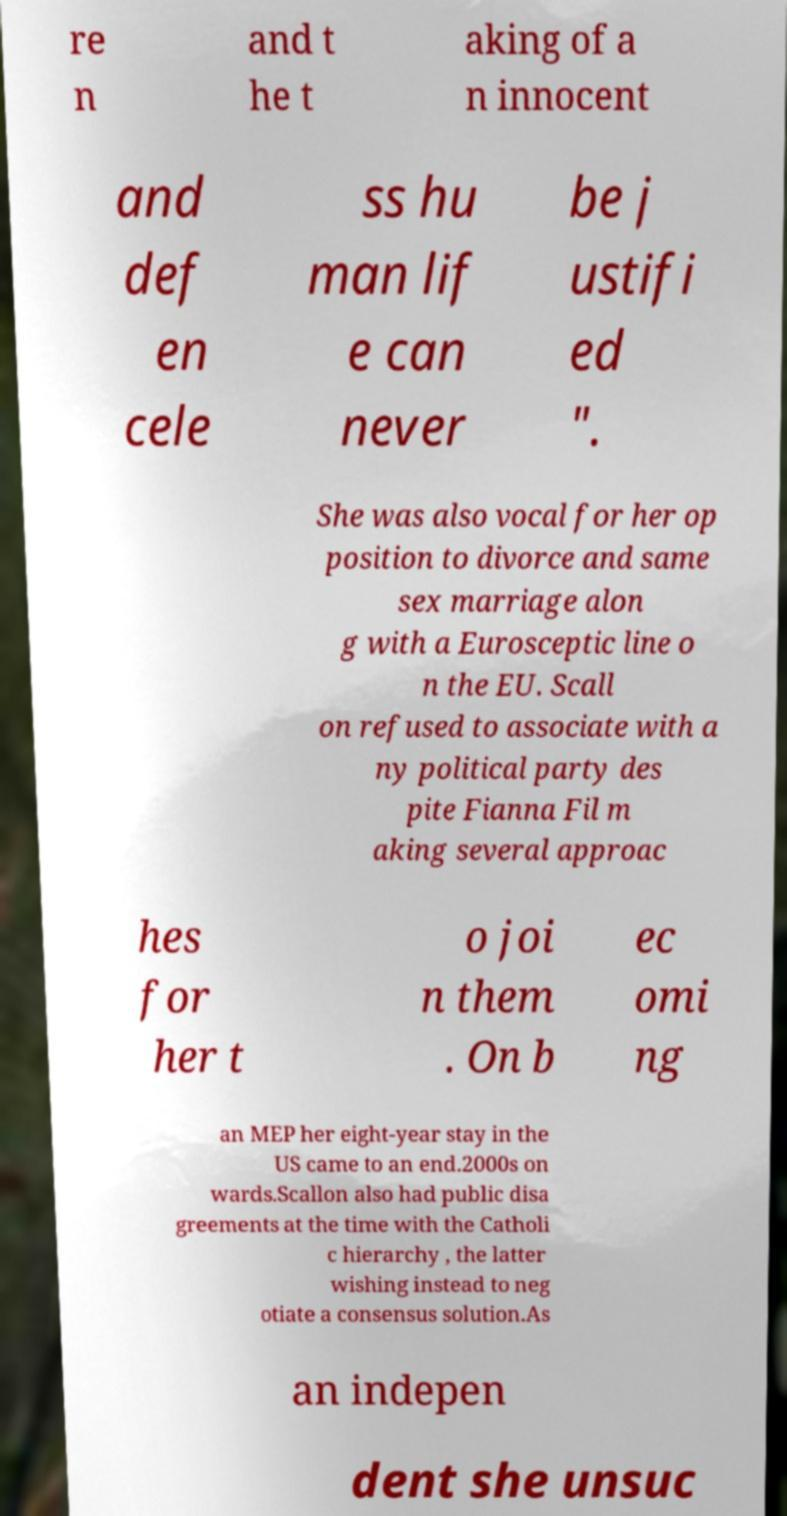Please identify and transcribe the text found in this image. re n and t he t aking of a n innocent and def en cele ss hu man lif e can never be j ustifi ed ". She was also vocal for her op position to divorce and same sex marriage alon g with a Eurosceptic line o n the EU. Scall on refused to associate with a ny political party des pite Fianna Fil m aking several approac hes for her t o joi n them . On b ec omi ng an MEP her eight-year stay in the US came to an end.2000s on wards.Scallon also had public disa greements at the time with the Catholi c hierarchy , the latter wishing instead to neg otiate a consensus solution.As an indepen dent she unsuc 